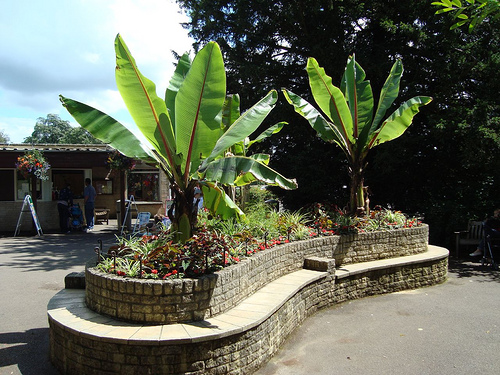<image>
Is the window behind the plant? Yes. From this viewpoint, the window is positioned behind the plant, with the plant partially or fully occluding the window. Is there a chair in the tree? No. The chair is not contained within the tree. These objects have a different spatial relationship. 